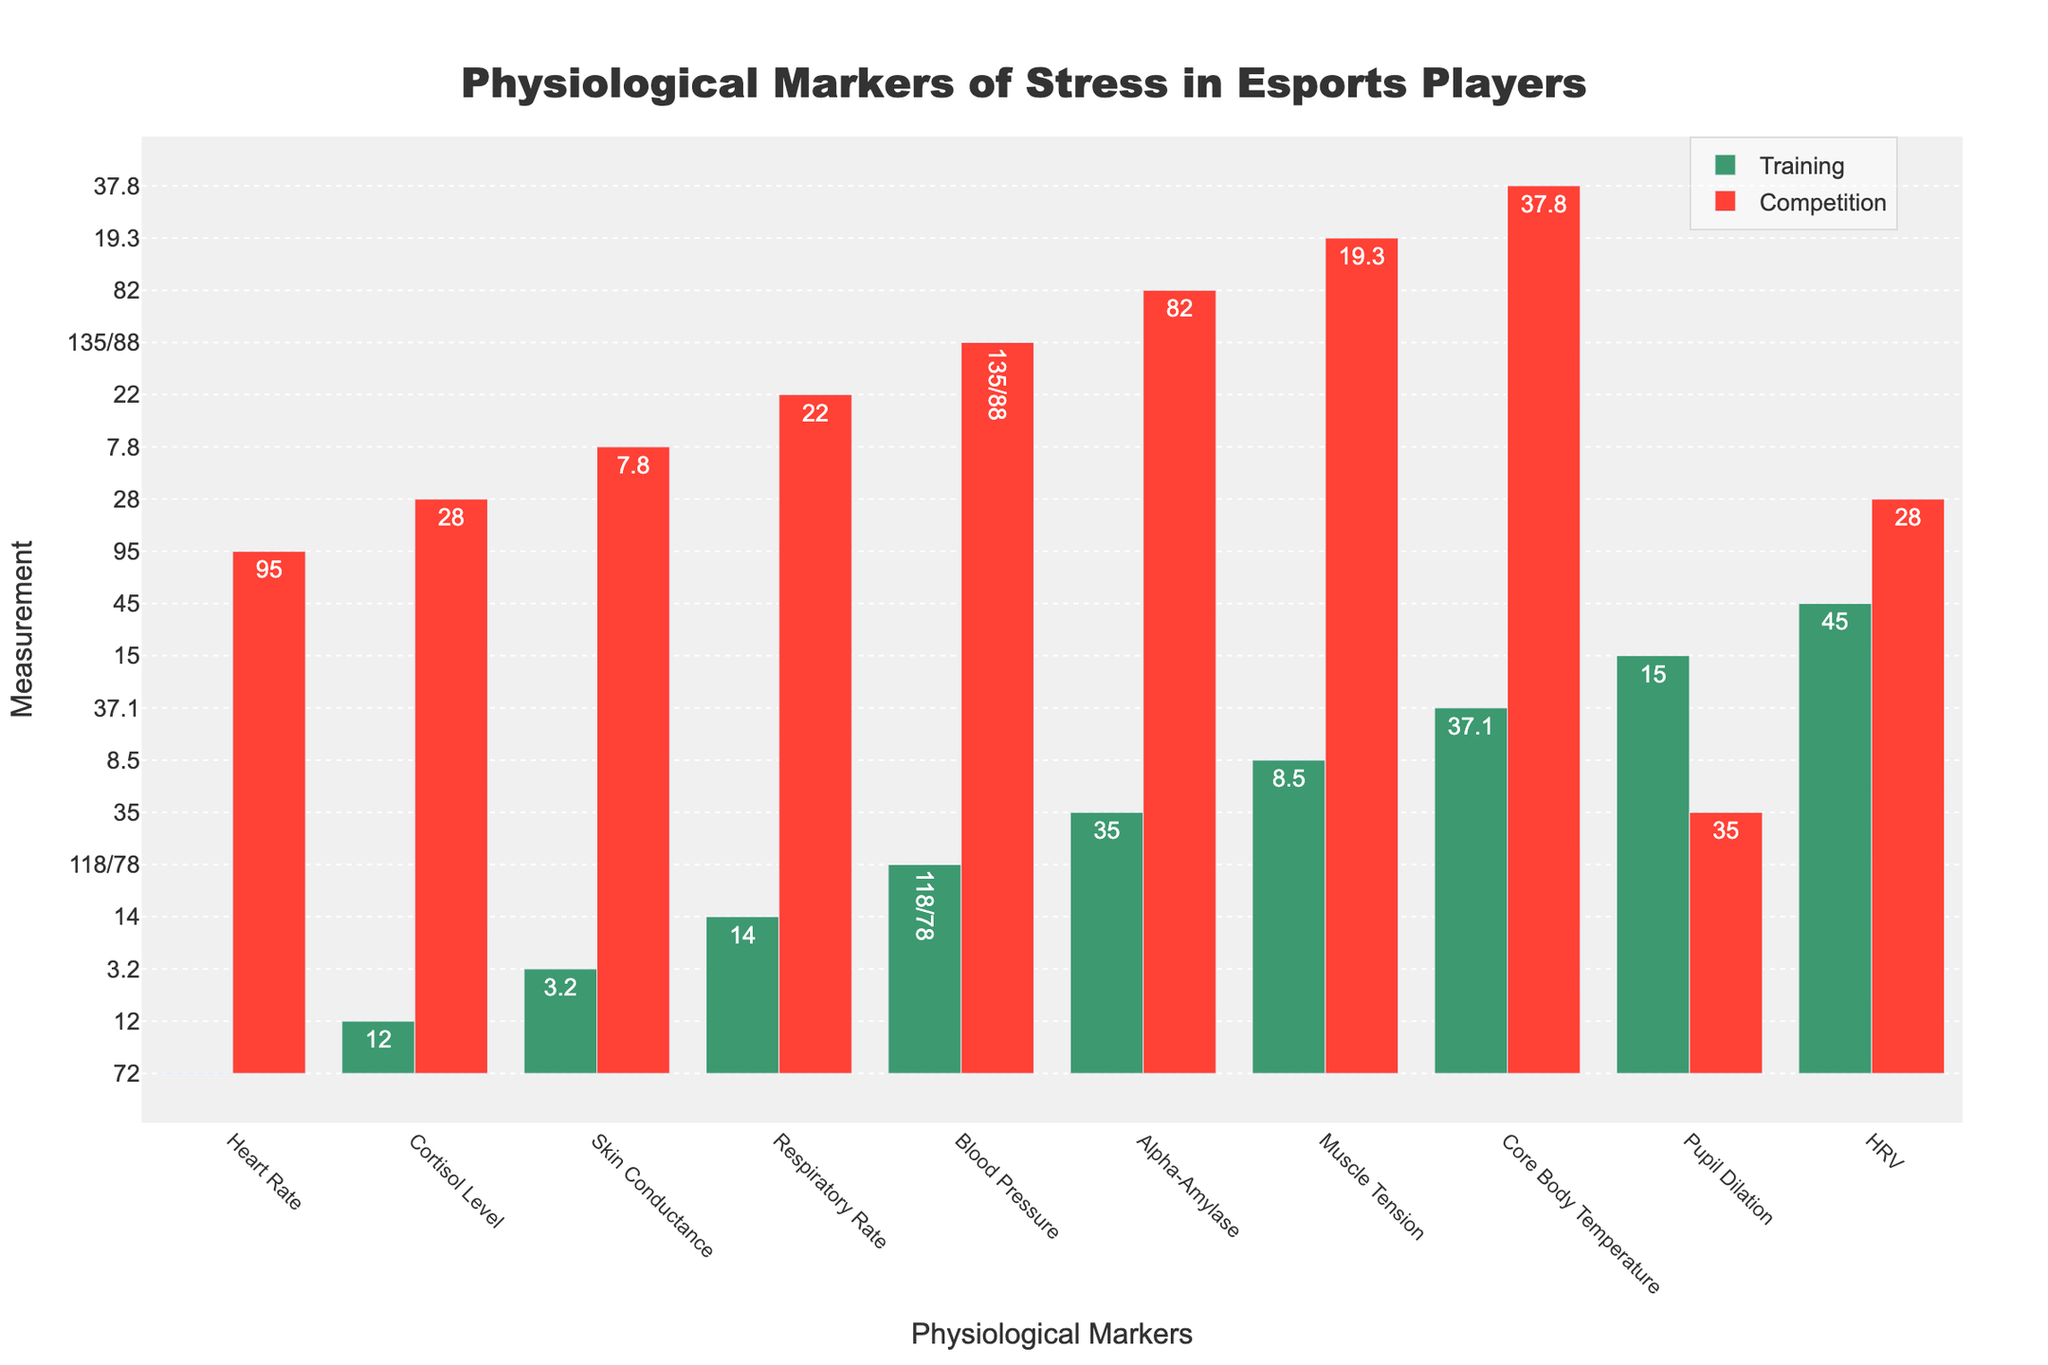What is the difference in Heart Rate between training and competition? Subtract the heart rate in training from the heart rate in competition: 95 - 72 = 23 bpm.
Answer: 23 bpm Which physiological marker shows the largest increase from training to competition? Compare the differences between training and competition for each marker. The largest difference is for Pupil Dilation: 35% - 15% = 20%.
Answer: Pupil Dilation What is the average value of Respiratory Rate during training and competition? Add Respiratory Rate during training and competition and divide by 2: (14 + 22) / 2 = 18 breaths/min.
Answer: 18 breaths/min In which two markers is the difference between training and competition less than 5 units? Calculate the difference for each marker and check where the value is less than 5 units: Core Body Temperature (0.7°C) and Heart Rate Variability (17).
Answer: Core Body Temperature, Heart Rate Variability Which marker has the smallest value during competition? Look at the competition values and find the smallest value: Skin Conductance (7.8 µS).
Answer: Skin Conductance How much higher are Cortisol Levels during competition compared to training? Subtract the training value from the competition value for Cortisol Levels: 28 - 12 = 16 ng/mL.
Answer: 16 ng/mL Which marker shows the least change between training and competition? Compare the differences between training and competition for each marker. The smallest change is in Heart Rate Variability: 45 - 28 = 17.
Answer: Heart Rate Variability By what percentage did Muscle Tension increase from training to competition? Find the difference in Muscle Tension between training and competition, divide by the training value, and multiply by 100: (19.3 - 8.5) / 8.5 * 100 = 127%.
Answer: 127% What is the total combined value of Alpha-Amylase during training and competition? Add the Alpha-Amylase values during training and competition: 35 + 82 = 117 U/mL.
Answer: 117 U/mL Which color represents the competition data on the bar chart? Identify the bar color for competition data from the chart. The bars are colored red for competition data.
Answer: Red 